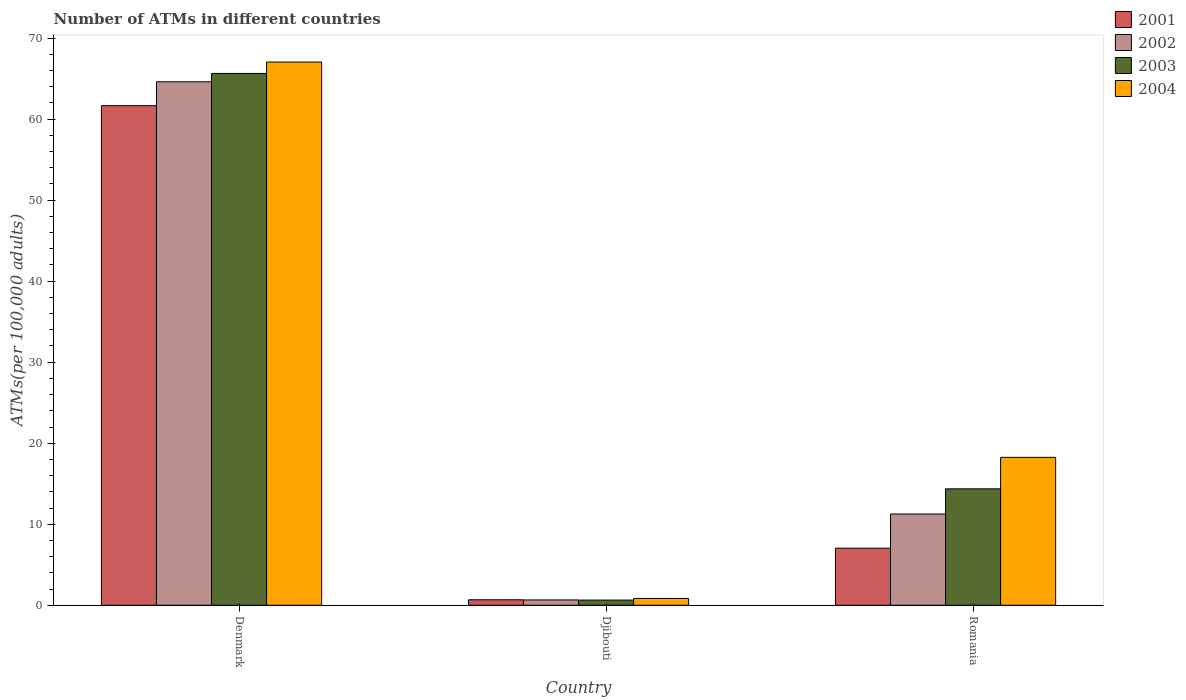How many different coloured bars are there?
Your response must be concise. 4. How many groups of bars are there?
Offer a very short reply. 3. Are the number of bars on each tick of the X-axis equal?
Offer a terse response. Yes. What is the label of the 1st group of bars from the left?
Keep it short and to the point. Denmark. In how many cases, is the number of bars for a given country not equal to the number of legend labels?
Provide a succinct answer. 0. What is the number of ATMs in 2002 in Djibouti?
Offer a very short reply. 0.66. Across all countries, what is the maximum number of ATMs in 2001?
Provide a short and direct response. 61.66. Across all countries, what is the minimum number of ATMs in 2004?
Make the answer very short. 0.84. In which country was the number of ATMs in 2002 minimum?
Give a very brief answer. Djibouti. What is the total number of ATMs in 2002 in the graph?
Make the answer very short. 76.52. What is the difference between the number of ATMs in 2003 in Djibouti and that in Romania?
Make the answer very short. -13.73. What is the difference between the number of ATMs in 2002 in Romania and the number of ATMs in 2003 in Djibouti?
Provide a succinct answer. 10.62. What is the average number of ATMs in 2004 per country?
Your answer should be very brief. 28.71. What is the difference between the number of ATMs of/in 2003 and number of ATMs of/in 2001 in Djibouti?
Offer a very short reply. -0.04. What is the ratio of the number of ATMs in 2001 in Djibouti to that in Romania?
Your answer should be compact. 0.1. Is the number of ATMs in 2003 in Denmark less than that in Romania?
Offer a terse response. No. Is the difference between the number of ATMs in 2003 in Denmark and Romania greater than the difference between the number of ATMs in 2001 in Denmark and Romania?
Provide a succinct answer. No. What is the difference between the highest and the second highest number of ATMs in 2004?
Your answer should be compact. -17.41. What is the difference between the highest and the lowest number of ATMs in 2004?
Keep it short and to the point. 66.2. Is it the case that in every country, the sum of the number of ATMs in 2001 and number of ATMs in 2004 is greater than the sum of number of ATMs in 2002 and number of ATMs in 2003?
Offer a terse response. No. What does the 2nd bar from the right in Djibouti represents?
Your answer should be compact. 2003. Is it the case that in every country, the sum of the number of ATMs in 2004 and number of ATMs in 2003 is greater than the number of ATMs in 2001?
Make the answer very short. Yes. How many countries are there in the graph?
Make the answer very short. 3. What is the difference between two consecutive major ticks on the Y-axis?
Keep it short and to the point. 10. What is the title of the graph?
Keep it short and to the point. Number of ATMs in different countries. What is the label or title of the Y-axis?
Keep it short and to the point. ATMs(per 100,0 adults). What is the ATMs(per 100,000 adults) of 2001 in Denmark?
Your response must be concise. 61.66. What is the ATMs(per 100,000 adults) of 2002 in Denmark?
Provide a short and direct response. 64.61. What is the ATMs(per 100,000 adults) of 2003 in Denmark?
Provide a short and direct response. 65.64. What is the ATMs(per 100,000 adults) of 2004 in Denmark?
Provide a succinct answer. 67.04. What is the ATMs(per 100,000 adults) in 2001 in Djibouti?
Your response must be concise. 0.68. What is the ATMs(per 100,000 adults) in 2002 in Djibouti?
Provide a succinct answer. 0.66. What is the ATMs(per 100,000 adults) in 2003 in Djibouti?
Your answer should be compact. 0.64. What is the ATMs(per 100,000 adults) of 2004 in Djibouti?
Keep it short and to the point. 0.84. What is the ATMs(per 100,000 adults) in 2001 in Romania?
Offer a terse response. 7.04. What is the ATMs(per 100,000 adults) in 2002 in Romania?
Provide a succinct answer. 11.26. What is the ATMs(per 100,000 adults) in 2003 in Romania?
Give a very brief answer. 14.37. What is the ATMs(per 100,000 adults) of 2004 in Romania?
Give a very brief answer. 18.26. Across all countries, what is the maximum ATMs(per 100,000 adults) of 2001?
Keep it short and to the point. 61.66. Across all countries, what is the maximum ATMs(per 100,000 adults) of 2002?
Offer a terse response. 64.61. Across all countries, what is the maximum ATMs(per 100,000 adults) of 2003?
Give a very brief answer. 65.64. Across all countries, what is the maximum ATMs(per 100,000 adults) of 2004?
Provide a short and direct response. 67.04. Across all countries, what is the minimum ATMs(per 100,000 adults) in 2001?
Offer a very short reply. 0.68. Across all countries, what is the minimum ATMs(per 100,000 adults) in 2002?
Keep it short and to the point. 0.66. Across all countries, what is the minimum ATMs(per 100,000 adults) in 2003?
Provide a succinct answer. 0.64. Across all countries, what is the minimum ATMs(per 100,000 adults) in 2004?
Your answer should be compact. 0.84. What is the total ATMs(per 100,000 adults) of 2001 in the graph?
Your response must be concise. 69.38. What is the total ATMs(per 100,000 adults) in 2002 in the graph?
Offer a terse response. 76.52. What is the total ATMs(per 100,000 adults) in 2003 in the graph?
Provide a short and direct response. 80.65. What is the total ATMs(per 100,000 adults) of 2004 in the graph?
Provide a succinct answer. 86.14. What is the difference between the ATMs(per 100,000 adults) in 2001 in Denmark and that in Djibouti?
Offer a very short reply. 60.98. What is the difference between the ATMs(per 100,000 adults) in 2002 in Denmark and that in Djibouti?
Offer a very short reply. 63.95. What is the difference between the ATMs(per 100,000 adults) in 2003 in Denmark and that in Djibouti?
Make the answer very short. 65. What is the difference between the ATMs(per 100,000 adults) in 2004 in Denmark and that in Djibouti?
Your answer should be compact. 66.2. What is the difference between the ATMs(per 100,000 adults) in 2001 in Denmark and that in Romania?
Offer a terse response. 54.61. What is the difference between the ATMs(per 100,000 adults) of 2002 in Denmark and that in Romania?
Provide a succinct answer. 53.35. What is the difference between the ATMs(per 100,000 adults) in 2003 in Denmark and that in Romania?
Offer a terse response. 51.27. What is the difference between the ATMs(per 100,000 adults) in 2004 in Denmark and that in Romania?
Your answer should be very brief. 48.79. What is the difference between the ATMs(per 100,000 adults) in 2001 in Djibouti and that in Romania?
Your response must be concise. -6.37. What is the difference between the ATMs(per 100,000 adults) in 2002 in Djibouti and that in Romania?
Offer a very short reply. -10.6. What is the difference between the ATMs(per 100,000 adults) of 2003 in Djibouti and that in Romania?
Make the answer very short. -13.73. What is the difference between the ATMs(per 100,000 adults) in 2004 in Djibouti and that in Romania?
Your answer should be compact. -17.41. What is the difference between the ATMs(per 100,000 adults) in 2001 in Denmark and the ATMs(per 100,000 adults) in 2002 in Djibouti?
Offer a terse response. 61. What is the difference between the ATMs(per 100,000 adults) of 2001 in Denmark and the ATMs(per 100,000 adults) of 2003 in Djibouti?
Make the answer very short. 61.02. What is the difference between the ATMs(per 100,000 adults) in 2001 in Denmark and the ATMs(per 100,000 adults) in 2004 in Djibouti?
Your answer should be very brief. 60.81. What is the difference between the ATMs(per 100,000 adults) in 2002 in Denmark and the ATMs(per 100,000 adults) in 2003 in Djibouti?
Your response must be concise. 63.97. What is the difference between the ATMs(per 100,000 adults) in 2002 in Denmark and the ATMs(per 100,000 adults) in 2004 in Djibouti?
Your answer should be very brief. 63.76. What is the difference between the ATMs(per 100,000 adults) in 2003 in Denmark and the ATMs(per 100,000 adults) in 2004 in Djibouti?
Provide a succinct answer. 64.79. What is the difference between the ATMs(per 100,000 adults) in 2001 in Denmark and the ATMs(per 100,000 adults) in 2002 in Romania?
Your answer should be compact. 50.4. What is the difference between the ATMs(per 100,000 adults) of 2001 in Denmark and the ATMs(per 100,000 adults) of 2003 in Romania?
Ensure brevity in your answer.  47.29. What is the difference between the ATMs(per 100,000 adults) of 2001 in Denmark and the ATMs(per 100,000 adults) of 2004 in Romania?
Keep it short and to the point. 43.4. What is the difference between the ATMs(per 100,000 adults) in 2002 in Denmark and the ATMs(per 100,000 adults) in 2003 in Romania?
Offer a terse response. 50.24. What is the difference between the ATMs(per 100,000 adults) of 2002 in Denmark and the ATMs(per 100,000 adults) of 2004 in Romania?
Your response must be concise. 46.35. What is the difference between the ATMs(per 100,000 adults) of 2003 in Denmark and the ATMs(per 100,000 adults) of 2004 in Romania?
Make the answer very short. 47.38. What is the difference between the ATMs(per 100,000 adults) in 2001 in Djibouti and the ATMs(per 100,000 adults) in 2002 in Romania?
Make the answer very short. -10.58. What is the difference between the ATMs(per 100,000 adults) in 2001 in Djibouti and the ATMs(per 100,000 adults) in 2003 in Romania?
Give a very brief answer. -13.69. What is the difference between the ATMs(per 100,000 adults) of 2001 in Djibouti and the ATMs(per 100,000 adults) of 2004 in Romania?
Offer a terse response. -17.58. What is the difference between the ATMs(per 100,000 adults) in 2002 in Djibouti and the ATMs(per 100,000 adults) in 2003 in Romania?
Make the answer very short. -13.71. What is the difference between the ATMs(per 100,000 adults) of 2002 in Djibouti and the ATMs(per 100,000 adults) of 2004 in Romania?
Offer a very short reply. -17.6. What is the difference between the ATMs(per 100,000 adults) in 2003 in Djibouti and the ATMs(per 100,000 adults) in 2004 in Romania?
Offer a terse response. -17.62. What is the average ATMs(per 100,000 adults) of 2001 per country?
Provide a succinct answer. 23.13. What is the average ATMs(per 100,000 adults) in 2002 per country?
Your answer should be compact. 25.51. What is the average ATMs(per 100,000 adults) of 2003 per country?
Provide a succinct answer. 26.88. What is the average ATMs(per 100,000 adults) in 2004 per country?
Provide a short and direct response. 28.71. What is the difference between the ATMs(per 100,000 adults) of 2001 and ATMs(per 100,000 adults) of 2002 in Denmark?
Your answer should be very brief. -2.95. What is the difference between the ATMs(per 100,000 adults) of 2001 and ATMs(per 100,000 adults) of 2003 in Denmark?
Your answer should be compact. -3.98. What is the difference between the ATMs(per 100,000 adults) in 2001 and ATMs(per 100,000 adults) in 2004 in Denmark?
Ensure brevity in your answer.  -5.39. What is the difference between the ATMs(per 100,000 adults) of 2002 and ATMs(per 100,000 adults) of 2003 in Denmark?
Provide a succinct answer. -1.03. What is the difference between the ATMs(per 100,000 adults) of 2002 and ATMs(per 100,000 adults) of 2004 in Denmark?
Your answer should be compact. -2.44. What is the difference between the ATMs(per 100,000 adults) in 2003 and ATMs(per 100,000 adults) in 2004 in Denmark?
Keep it short and to the point. -1.41. What is the difference between the ATMs(per 100,000 adults) in 2001 and ATMs(per 100,000 adults) in 2002 in Djibouti?
Offer a very short reply. 0.02. What is the difference between the ATMs(per 100,000 adults) of 2001 and ATMs(per 100,000 adults) of 2003 in Djibouti?
Keep it short and to the point. 0.04. What is the difference between the ATMs(per 100,000 adults) in 2001 and ATMs(per 100,000 adults) in 2004 in Djibouti?
Your answer should be compact. -0.17. What is the difference between the ATMs(per 100,000 adults) of 2002 and ATMs(per 100,000 adults) of 2003 in Djibouti?
Make the answer very short. 0.02. What is the difference between the ATMs(per 100,000 adults) in 2002 and ATMs(per 100,000 adults) in 2004 in Djibouti?
Ensure brevity in your answer.  -0.19. What is the difference between the ATMs(per 100,000 adults) in 2003 and ATMs(per 100,000 adults) in 2004 in Djibouti?
Give a very brief answer. -0.21. What is the difference between the ATMs(per 100,000 adults) of 2001 and ATMs(per 100,000 adults) of 2002 in Romania?
Your answer should be compact. -4.21. What is the difference between the ATMs(per 100,000 adults) of 2001 and ATMs(per 100,000 adults) of 2003 in Romania?
Offer a very short reply. -7.32. What is the difference between the ATMs(per 100,000 adults) of 2001 and ATMs(per 100,000 adults) of 2004 in Romania?
Ensure brevity in your answer.  -11.21. What is the difference between the ATMs(per 100,000 adults) in 2002 and ATMs(per 100,000 adults) in 2003 in Romania?
Offer a terse response. -3.11. What is the difference between the ATMs(per 100,000 adults) of 2002 and ATMs(per 100,000 adults) of 2004 in Romania?
Ensure brevity in your answer.  -7. What is the difference between the ATMs(per 100,000 adults) in 2003 and ATMs(per 100,000 adults) in 2004 in Romania?
Your response must be concise. -3.89. What is the ratio of the ATMs(per 100,000 adults) of 2001 in Denmark to that in Djibouti?
Your answer should be compact. 91.18. What is the ratio of the ATMs(per 100,000 adults) in 2002 in Denmark to that in Djibouti?
Give a very brief answer. 98.45. What is the ratio of the ATMs(per 100,000 adults) of 2003 in Denmark to that in Djibouti?
Your response must be concise. 102.88. What is the ratio of the ATMs(per 100,000 adults) in 2004 in Denmark to that in Djibouti?
Keep it short and to the point. 79.46. What is the ratio of the ATMs(per 100,000 adults) of 2001 in Denmark to that in Romania?
Your answer should be compact. 8.75. What is the ratio of the ATMs(per 100,000 adults) of 2002 in Denmark to that in Romania?
Give a very brief answer. 5.74. What is the ratio of the ATMs(per 100,000 adults) in 2003 in Denmark to that in Romania?
Your answer should be very brief. 4.57. What is the ratio of the ATMs(per 100,000 adults) of 2004 in Denmark to that in Romania?
Offer a terse response. 3.67. What is the ratio of the ATMs(per 100,000 adults) of 2001 in Djibouti to that in Romania?
Offer a terse response. 0.1. What is the ratio of the ATMs(per 100,000 adults) in 2002 in Djibouti to that in Romania?
Your answer should be very brief. 0.06. What is the ratio of the ATMs(per 100,000 adults) of 2003 in Djibouti to that in Romania?
Make the answer very short. 0.04. What is the ratio of the ATMs(per 100,000 adults) in 2004 in Djibouti to that in Romania?
Offer a terse response. 0.05. What is the difference between the highest and the second highest ATMs(per 100,000 adults) in 2001?
Your response must be concise. 54.61. What is the difference between the highest and the second highest ATMs(per 100,000 adults) in 2002?
Offer a very short reply. 53.35. What is the difference between the highest and the second highest ATMs(per 100,000 adults) of 2003?
Your response must be concise. 51.27. What is the difference between the highest and the second highest ATMs(per 100,000 adults) in 2004?
Your response must be concise. 48.79. What is the difference between the highest and the lowest ATMs(per 100,000 adults) of 2001?
Give a very brief answer. 60.98. What is the difference between the highest and the lowest ATMs(per 100,000 adults) of 2002?
Your response must be concise. 63.95. What is the difference between the highest and the lowest ATMs(per 100,000 adults) of 2003?
Offer a terse response. 65. What is the difference between the highest and the lowest ATMs(per 100,000 adults) of 2004?
Provide a succinct answer. 66.2. 